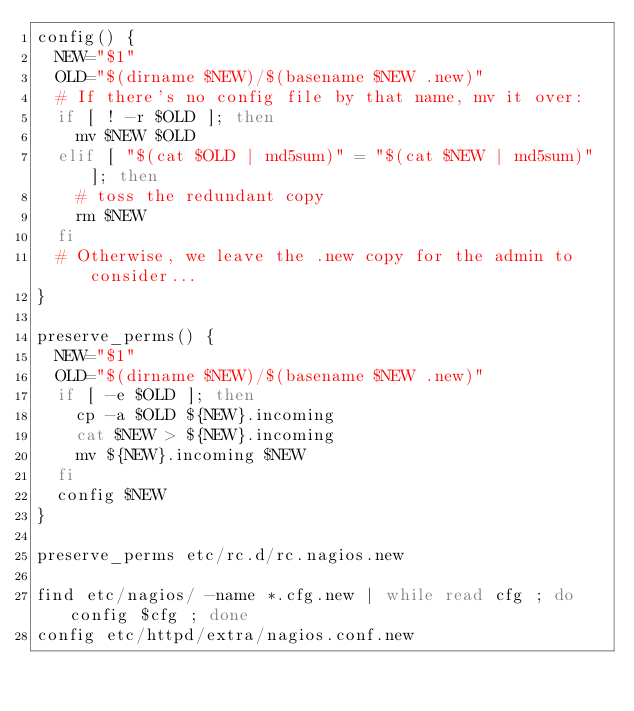<code> <loc_0><loc_0><loc_500><loc_500><_Bash_>config() {
  NEW="$1"
  OLD="$(dirname $NEW)/$(basename $NEW .new)"
  # If there's no config file by that name, mv it over:
  if [ ! -r $OLD ]; then
    mv $NEW $OLD
  elif [ "$(cat $OLD | md5sum)" = "$(cat $NEW | md5sum)" ]; then
    # toss the redundant copy
    rm $NEW
  fi
  # Otherwise, we leave the .new copy for the admin to consider...
}

preserve_perms() {
  NEW="$1"
  OLD="$(dirname $NEW)/$(basename $NEW .new)"
  if [ -e $OLD ]; then
    cp -a $OLD ${NEW}.incoming
    cat $NEW > ${NEW}.incoming
    mv ${NEW}.incoming $NEW
  fi
  config $NEW
}

preserve_perms etc/rc.d/rc.nagios.new

find etc/nagios/ -name *.cfg.new | while read cfg ; do config $cfg ; done
config etc/httpd/extra/nagios.conf.new

</code> 